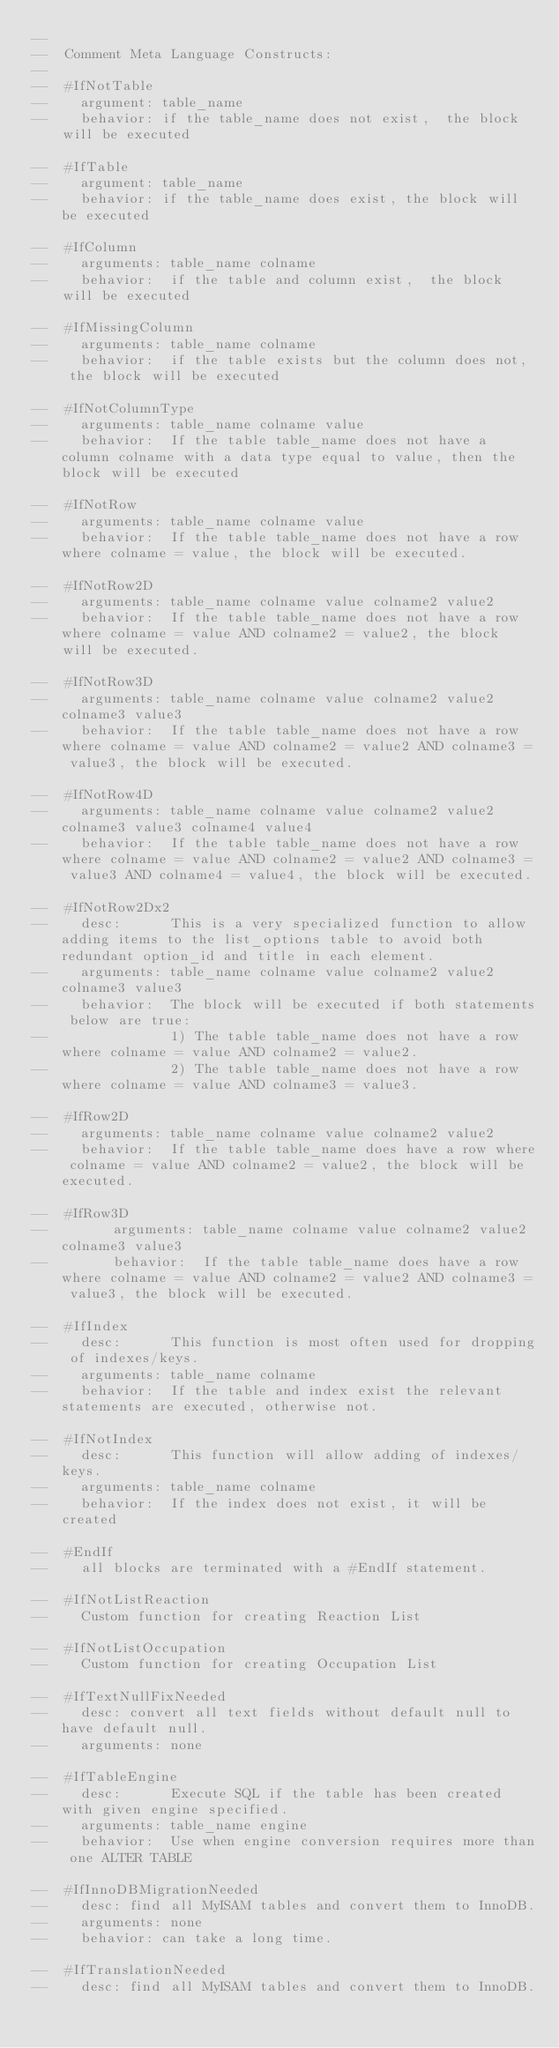Convert code to text. <code><loc_0><loc_0><loc_500><loc_500><_SQL_>--
--  Comment Meta Language Constructs:
--
--  #IfNotTable
--    argument: table_name
--    behavior: if the table_name does not exist,  the block will be executed

--  #IfTable
--    argument: table_name
--    behavior: if the table_name does exist, the block will be executed

--  #IfColumn
--    arguments: table_name colname
--    behavior:  if the table and column exist,  the block will be executed

--  #IfMissingColumn
--    arguments: table_name colname
--    behavior:  if the table exists but the column does not,  the block will be executed

--  #IfNotColumnType
--    arguments: table_name colname value
--    behavior:  If the table table_name does not have a column colname with a data type equal to value, then the block will be executed

--  #IfNotRow
--    arguments: table_name colname value
--    behavior:  If the table table_name does not have a row where colname = value, the block will be executed.

--  #IfNotRow2D
--    arguments: table_name colname value colname2 value2
--    behavior:  If the table table_name does not have a row where colname = value AND colname2 = value2, the block will be executed.

--  #IfNotRow3D
--    arguments: table_name colname value colname2 value2 colname3 value3
--    behavior:  If the table table_name does not have a row where colname = value AND colname2 = value2 AND colname3 = value3, the block will be executed.

--  #IfNotRow4D
--    arguments: table_name colname value colname2 value2 colname3 value3 colname4 value4
--    behavior:  If the table table_name does not have a row where colname = value AND colname2 = value2 AND colname3 = value3 AND colname4 = value4, the block will be executed.

--  #IfNotRow2Dx2
--    desc:      This is a very specialized function to allow adding items to the list_options table to avoid both redundant option_id and title in each element.
--    arguments: table_name colname value colname2 value2 colname3 value3
--    behavior:  The block will be executed if both statements below are true:
--               1) The table table_name does not have a row where colname = value AND colname2 = value2.
--               2) The table table_name does not have a row where colname = value AND colname3 = value3.

--  #IfRow2D
--    arguments: table_name colname value colname2 value2
--    behavior:  If the table table_name does have a row where colname = value AND colname2 = value2, the block will be executed.

--  #IfRow3D
--        arguments: table_name colname value colname2 value2 colname3 value3
--        behavior:  If the table table_name does have a row where colname = value AND colname2 = value2 AND colname3 = value3, the block will be executed.

--  #IfIndex
--    desc:      This function is most often used for dropping of indexes/keys.
--    arguments: table_name colname
--    behavior:  If the table and index exist the relevant statements are executed, otherwise not.

--  #IfNotIndex
--    desc:      This function will allow adding of indexes/keys.
--    arguments: table_name colname
--    behavior:  If the index does not exist, it will be created

--  #EndIf
--    all blocks are terminated with a #EndIf statement.

--  #IfNotListReaction
--    Custom function for creating Reaction List

--  #IfNotListOccupation
--    Custom function for creating Occupation List

--  #IfTextNullFixNeeded
--    desc: convert all text fields without default null to have default null.
--    arguments: none

--  #IfTableEngine
--    desc:      Execute SQL if the table has been created with given engine specified.
--    arguments: table_name engine
--    behavior:  Use when engine conversion requires more than one ALTER TABLE

--  #IfInnoDBMigrationNeeded
--    desc: find all MyISAM tables and convert them to InnoDB.
--    arguments: none
--    behavior: can take a long time.

--  #IfTranslationNeeded
--    desc: find all MyISAM tables and convert them to InnoDB.</code> 